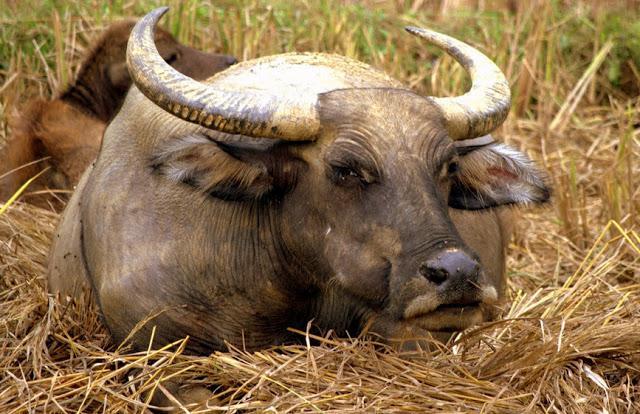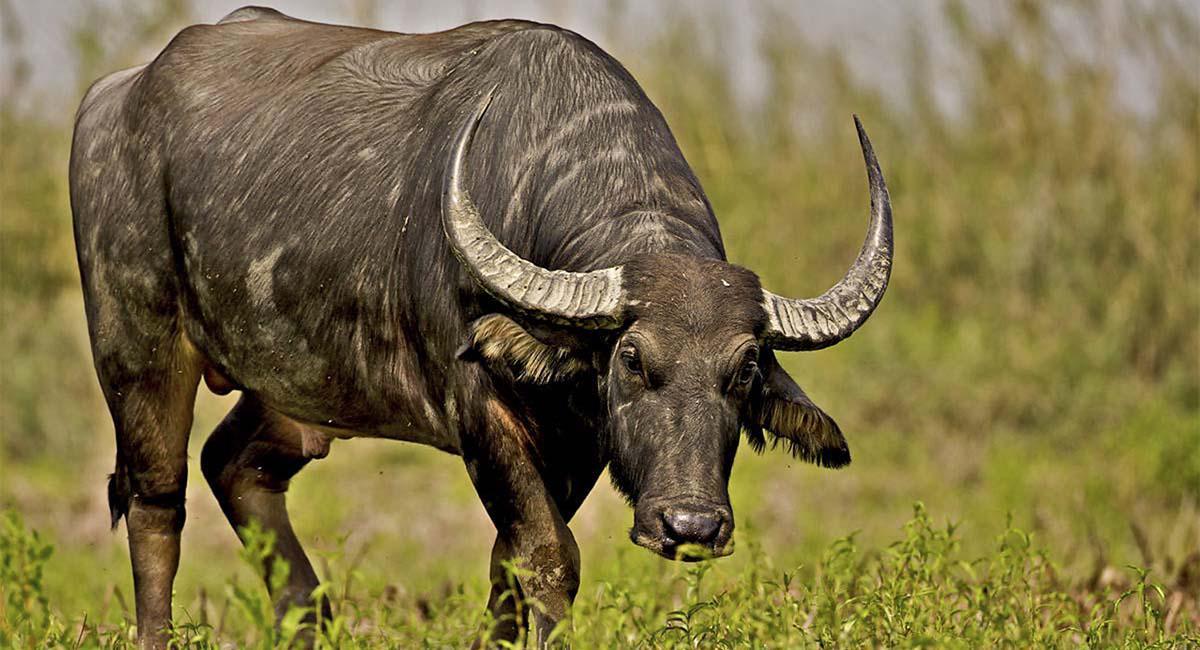The first image is the image on the left, the second image is the image on the right. Evaluate the accuracy of this statement regarding the images: "There are exactly two animals who are facing in the same direction.". Is it true? Answer yes or no. Yes. The first image is the image on the left, the second image is the image on the right. Given the left and right images, does the statement "The big horned cow on the left is brown and not black." hold true? Answer yes or no. Yes. 